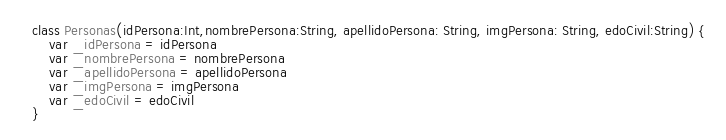<code> <loc_0><loc_0><loc_500><loc_500><_Kotlin_>class Personas(idPersona:Int,nombrePersona:String, apellidoPersona: String, imgPersona: String, edoCivil:String) {
    var _idPersona = idPersona
    var _nombrePersona = nombrePersona
    var _apellidoPersona = apellidoPersona
    var _imgPersona = imgPersona
    var _edoCivil = edoCivil
}</code> 